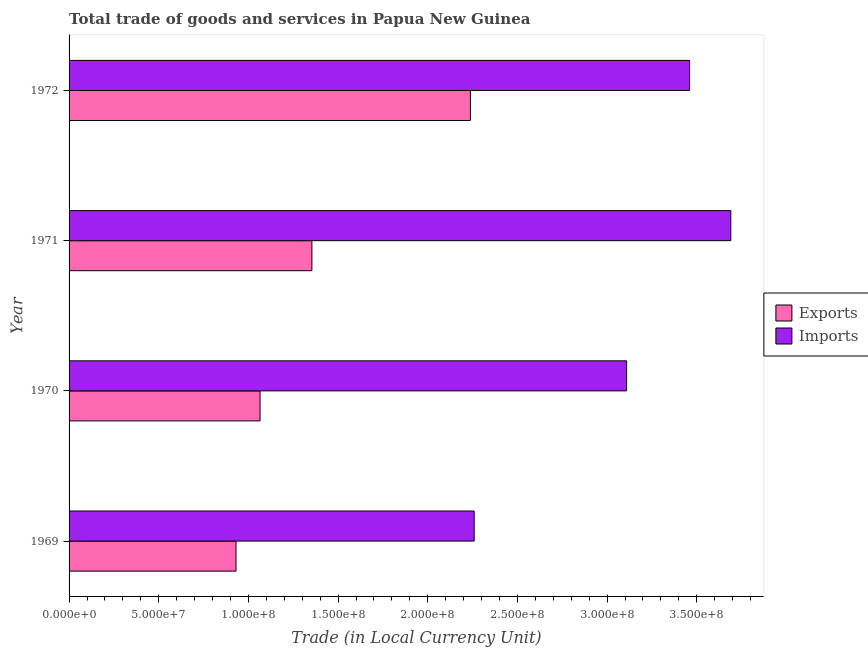Are the number of bars on each tick of the Y-axis equal?
Your answer should be compact. Yes. How many bars are there on the 4th tick from the top?
Your answer should be very brief. 2. What is the label of the 2nd group of bars from the top?
Make the answer very short. 1971. What is the imports of goods and services in 1970?
Offer a very short reply. 3.11e+08. Across all years, what is the maximum imports of goods and services?
Your answer should be compact. 3.69e+08. Across all years, what is the minimum export of goods and services?
Make the answer very short. 9.31e+07. In which year was the imports of goods and services maximum?
Offer a terse response. 1971. In which year was the imports of goods and services minimum?
Offer a terse response. 1969. What is the total export of goods and services in the graph?
Provide a short and direct response. 5.59e+08. What is the difference between the imports of goods and services in 1969 and that in 1971?
Offer a terse response. -1.43e+08. What is the difference between the export of goods and services in 1970 and the imports of goods and services in 1971?
Provide a succinct answer. -2.62e+08. What is the average imports of goods and services per year?
Your answer should be compact. 3.13e+08. In the year 1972, what is the difference between the export of goods and services and imports of goods and services?
Offer a terse response. -1.22e+08. In how many years, is the imports of goods and services greater than 210000000 LCU?
Provide a succinct answer. 4. What is the ratio of the imports of goods and services in 1970 to that in 1971?
Provide a short and direct response. 0.84. What is the difference between the highest and the second highest imports of goods and services?
Provide a short and direct response. 2.30e+07. What is the difference between the highest and the lowest imports of goods and services?
Ensure brevity in your answer.  1.43e+08. In how many years, is the export of goods and services greater than the average export of goods and services taken over all years?
Offer a terse response. 1. What does the 1st bar from the top in 1969 represents?
Ensure brevity in your answer.  Imports. What does the 1st bar from the bottom in 1972 represents?
Give a very brief answer. Exports. What is the difference between two consecutive major ticks on the X-axis?
Your response must be concise. 5.00e+07. Does the graph contain any zero values?
Offer a very short reply. No. Does the graph contain grids?
Provide a succinct answer. No. Where does the legend appear in the graph?
Keep it short and to the point. Center right. How many legend labels are there?
Your answer should be very brief. 2. What is the title of the graph?
Your answer should be very brief. Total trade of goods and services in Papua New Guinea. What is the label or title of the X-axis?
Offer a terse response. Trade (in Local Currency Unit). What is the Trade (in Local Currency Unit) of Exports in 1969?
Make the answer very short. 9.31e+07. What is the Trade (in Local Currency Unit) in Imports in 1969?
Ensure brevity in your answer.  2.26e+08. What is the Trade (in Local Currency Unit) of Exports in 1970?
Your answer should be compact. 1.06e+08. What is the Trade (in Local Currency Unit) of Imports in 1970?
Give a very brief answer. 3.11e+08. What is the Trade (in Local Currency Unit) in Exports in 1971?
Make the answer very short. 1.35e+08. What is the Trade (in Local Currency Unit) in Imports in 1971?
Your answer should be very brief. 3.69e+08. What is the Trade (in Local Currency Unit) in Exports in 1972?
Offer a terse response. 2.24e+08. What is the Trade (in Local Currency Unit) of Imports in 1972?
Keep it short and to the point. 3.46e+08. Across all years, what is the maximum Trade (in Local Currency Unit) in Exports?
Your response must be concise. 2.24e+08. Across all years, what is the maximum Trade (in Local Currency Unit) in Imports?
Your response must be concise. 3.69e+08. Across all years, what is the minimum Trade (in Local Currency Unit) of Exports?
Ensure brevity in your answer.  9.31e+07. Across all years, what is the minimum Trade (in Local Currency Unit) of Imports?
Provide a succinct answer. 2.26e+08. What is the total Trade (in Local Currency Unit) in Exports in the graph?
Give a very brief answer. 5.59e+08. What is the total Trade (in Local Currency Unit) of Imports in the graph?
Provide a short and direct response. 1.25e+09. What is the difference between the Trade (in Local Currency Unit) in Exports in 1969 and that in 1970?
Your response must be concise. -1.34e+07. What is the difference between the Trade (in Local Currency Unit) of Imports in 1969 and that in 1970?
Your answer should be very brief. -8.50e+07. What is the difference between the Trade (in Local Currency Unit) in Exports in 1969 and that in 1971?
Provide a short and direct response. -4.23e+07. What is the difference between the Trade (in Local Currency Unit) of Imports in 1969 and that in 1971?
Your response must be concise. -1.43e+08. What is the difference between the Trade (in Local Currency Unit) in Exports in 1969 and that in 1972?
Your answer should be very brief. -1.31e+08. What is the difference between the Trade (in Local Currency Unit) in Imports in 1969 and that in 1972?
Keep it short and to the point. -1.20e+08. What is the difference between the Trade (in Local Currency Unit) of Exports in 1970 and that in 1971?
Keep it short and to the point. -2.89e+07. What is the difference between the Trade (in Local Currency Unit) in Imports in 1970 and that in 1971?
Give a very brief answer. -5.81e+07. What is the difference between the Trade (in Local Currency Unit) of Exports in 1970 and that in 1972?
Your answer should be compact. -1.17e+08. What is the difference between the Trade (in Local Currency Unit) in Imports in 1970 and that in 1972?
Provide a short and direct response. -3.51e+07. What is the difference between the Trade (in Local Currency Unit) of Exports in 1971 and that in 1972?
Your response must be concise. -8.84e+07. What is the difference between the Trade (in Local Currency Unit) of Imports in 1971 and that in 1972?
Provide a short and direct response. 2.30e+07. What is the difference between the Trade (in Local Currency Unit) of Exports in 1969 and the Trade (in Local Currency Unit) of Imports in 1970?
Your answer should be compact. -2.18e+08. What is the difference between the Trade (in Local Currency Unit) of Exports in 1969 and the Trade (in Local Currency Unit) of Imports in 1971?
Your response must be concise. -2.76e+08. What is the difference between the Trade (in Local Currency Unit) in Exports in 1969 and the Trade (in Local Currency Unit) in Imports in 1972?
Give a very brief answer. -2.53e+08. What is the difference between the Trade (in Local Currency Unit) of Exports in 1970 and the Trade (in Local Currency Unit) of Imports in 1971?
Ensure brevity in your answer.  -2.62e+08. What is the difference between the Trade (in Local Currency Unit) in Exports in 1970 and the Trade (in Local Currency Unit) in Imports in 1972?
Make the answer very short. -2.40e+08. What is the difference between the Trade (in Local Currency Unit) in Exports in 1971 and the Trade (in Local Currency Unit) in Imports in 1972?
Offer a very short reply. -2.11e+08. What is the average Trade (in Local Currency Unit) of Exports per year?
Your response must be concise. 1.40e+08. What is the average Trade (in Local Currency Unit) of Imports per year?
Offer a very short reply. 3.13e+08. In the year 1969, what is the difference between the Trade (in Local Currency Unit) of Exports and Trade (in Local Currency Unit) of Imports?
Make the answer very short. -1.33e+08. In the year 1970, what is the difference between the Trade (in Local Currency Unit) of Exports and Trade (in Local Currency Unit) of Imports?
Give a very brief answer. -2.04e+08. In the year 1971, what is the difference between the Trade (in Local Currency Unit) in Exports and Trade (in Local Currency Unit) in Imports?
Provide a short and direct response. -2.34e+08. In the year 1972, what is the difference between the Trade (in Local Currency Unit) of Exports and Trade (in Local Currency Unit) of Imports?
Offer a very short reply. -1.22e+08. What is the ratio of the Trade (in Local Currency Unit) of Exports in 1969 to that in 1970?
Make the answer very short. 0.87. What is the ratio of the Trade (in Local Currency Unit) in Imports in 1969 to that in 1970?
Your answer should be compact. 0.73. What is the ratio of the Trade (in Local Currency Unit) of Exports in 1969 to that in 1971?
Your answer should be very brief. 0.69. What is the ratio of the Trade (in Local Currency Unit) in Imports in 1969 to that in 1971?
Your answer should be very brief. 0.61. What is the ratio of the Trade (in Local Currency Unit) of Exports in 1969 to that in 1972?
Make the answer very short. 0.42. What is the ratio of the Trade (in Local Currency Unit) of Imports in 1969 to that in 1972?
Keep it short and to the point. 0.65. What is the ratio of the Trade (in Local Currency Unit) of Exports in 1970 to that in 1971?
Offer a very short reply. 0.79. What is the ratio of the Trade (in Local Currency Unit) in Imports in 1970 to that in 1971?
Offer a terse response. 0.84. What is the ratio of the Trade (in Local Currency Unit) of Exports in 1970 to that in 1972?
Your answer should be compact. 0.48. What is the ratio of the Trade (in Local Currency Unit) in Imports in 1970 to that in 1972?
Offer a very short reply. 0.9. What is the ratio of the Trade (in Local Currency Unit) in Exports in 1971 to that in 1972?
Your answer should be compact. 0.6. What is the ratio of the Trade (in Local Currency Unit) of Imports in 1971 to that in 1972?
Provide a succinct answer. 1.07. What is the difference between the highest and the second highest Trade (in Local Currency Unit) in Exports?
Keep it short and to the point. 8.84e+07. What is the difference between the highest and the second highest Trade (in Local Currency Unit) in Imports?
Your response must be concise. 2.30e+07. What is the difference between the highest and the lowest Trade (in Local Currency Unit) of Exports?
Offer a terse response. 1.31e+08. What is the difference between the highest and the lowest Trade (in Local Currency Unit) of Imports?
Your answer should be very brief. 1.43e+08. 